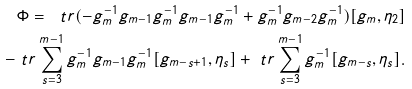<formula> <loc_0><loc_0><loc_500><loc_500>\Phi = \ t r ( - g _ { m } ^ { - 1 } g _ { m - 1 } g _ { m } ^ { - 1 } g _ { m - 1 } g _ { m } ^ { - 1 } + g _ { m } ^ { - 1 } g _ { m - 2 } g _ { m } ^ { - 1 } ) [ g _ { m } , \eta _ { 2 } ] \\ - \ t r \sum _ { s = 3 } ^ { m - 1 } g _ { m } ^ { - 1 } g _ { m - 1 } g _ { m } ^ { - 1 } [ g _ { m - s + 1 } , \eta _ { s } ] + \ t r \sum _ { s = 3 } ^ { m - 1 } g _ { m } ^ { - 1 } [ g _ { m - s } , \eta _ { s } ] .</formula> 